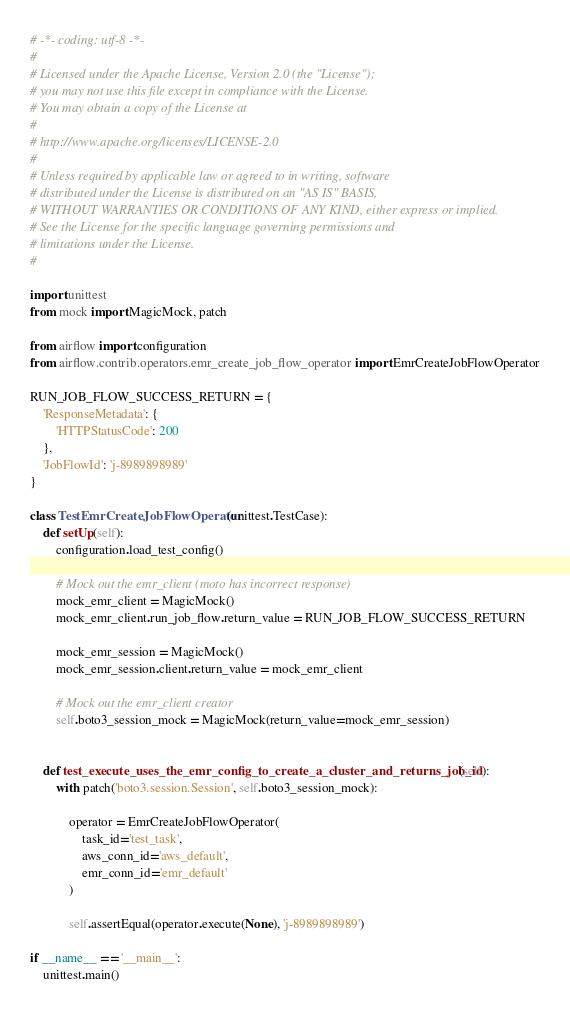Convert code to text. <code><loc_0><loc_0><loc_500><loc_500><_Python_># -*- coding: utf-8 -*-
#
# Licensed under the Apache License, Version 2.0 (the "License");
# you may not use this file except in compliance with the License.
# You may obtain a copy of the License at
#
# http://www.apache.org/licenses/LICENSE-2.0
#
# Unless required by applicable law or agreed to in writing, software
# distributed under the License is distributed on an "AS IS" BASIS,
# WITHOUT WARRANTIES OR CONDITIONS OF ANY KIND, either express or implied.
# See the License for the specific language governing permissions and
# limitations under the License.
#

import unittest
from mock import MagicMock, patch

from airflow import configuration
from airflow.contrib.operators.emr_create_job_flow_operator import EmrCreateJobFlowOperator

RUN_JOB_FLOW_SUCCESS_RETURN = {
    'ResponseMetadata': {
        'HTTPStatusCode': 200
    },
    'JobFlowId': 'j-8989898989'
}

class TestEmrCreateJobFlowOperator(unittest.TestCase):
    def setUp(self):
        configuration.load_test_config()

        # Mock out the emr_client (moto has incorrect response)
        mock_emr_client = MagicMock()
        mock_emr_client.run_job_flow.return_value = RUN_JOB_FLOW_SUCCESS_RETURN

        mock_emr_session = MagicMock()
        mock_emr_session.client.return_value = mock_emr_client

        # Mock out the emr_client creator
        self.boto3_session_mock = MagicMock(return_value=mock_emr_session)


    def test_execute_uses_the_emr_config_to_create_a_cluster_and_returns_job_id(self):
        with patch('boto3.session.Session', self.boto3_session_mock):

            operator = EmrCreateJobFlowOperator(
                task_id='test_task',
                aws_conn_id='aws_default',
                emr_conn_id='emr_default'
            )

            self.assertEqual(operator.execute(None), 'j-8989898989')

if __name__ == '__main__':
    unittest.main()
</code> 